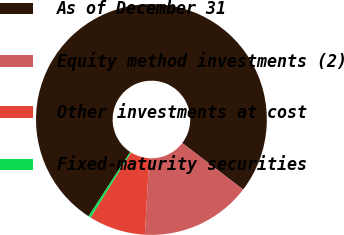Convert chart. <chart><loc_0><loc_0><loc_500><loc_500><pie_chart><fcel>As of December 31<fcel>Equity method investments (2)<fcel>Other investments at cost<fcel>Fixed-maturity securities<nl><fcel>76.22%<fcel>15.52%<fcel>7.93%<fcel>0.34%<nl></chart> 